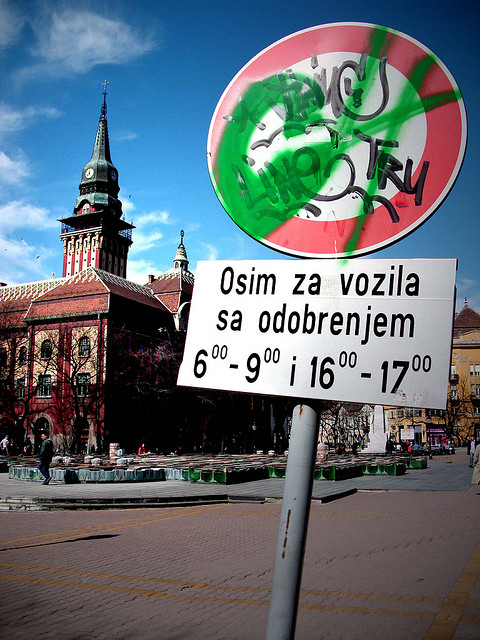Identify the text contained in this image. Osim za vozila sa odobrenjem 00 00 00 i 00 17 16 9 6 TRY LINE 